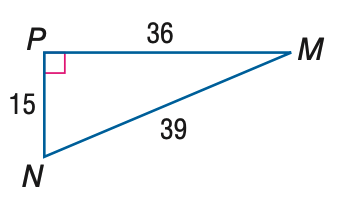Answer the mathemtical geometry problem and directly provide the correct option letter.
Question: Express the ratio of \cos M as a decimal to the nearest hundredth.
Choices: A: 0.38 B: 0.42 C: 0.92 D: 2.40 C 